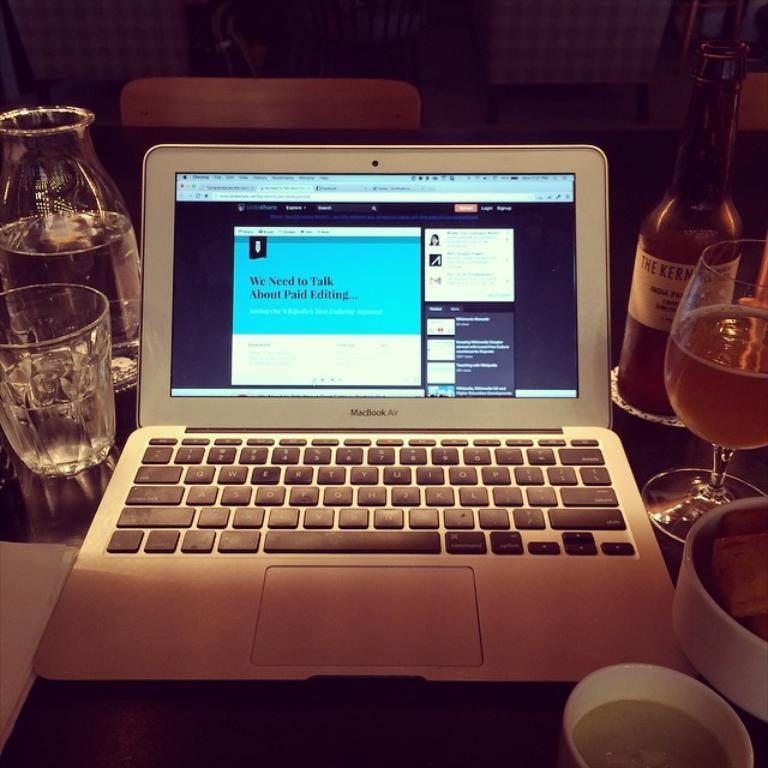What electronic device is visible in the image? There is a laptop in the image. Where is the laptop placed? The laptop is placed on a table. What beverage-related items can be seen in the image? There are wine glasses and a wine bottle in the image. What furniture item is visible in the background of the image? There is a chair in the background of the image. What type of background is present in the image? There is a wall in the background of the image. What type of lumber is being used to construct the van in the image? There is no van or lumber present in the image; it features a laptop, wine glasses, a wine bottle, a chair, and a wall. 